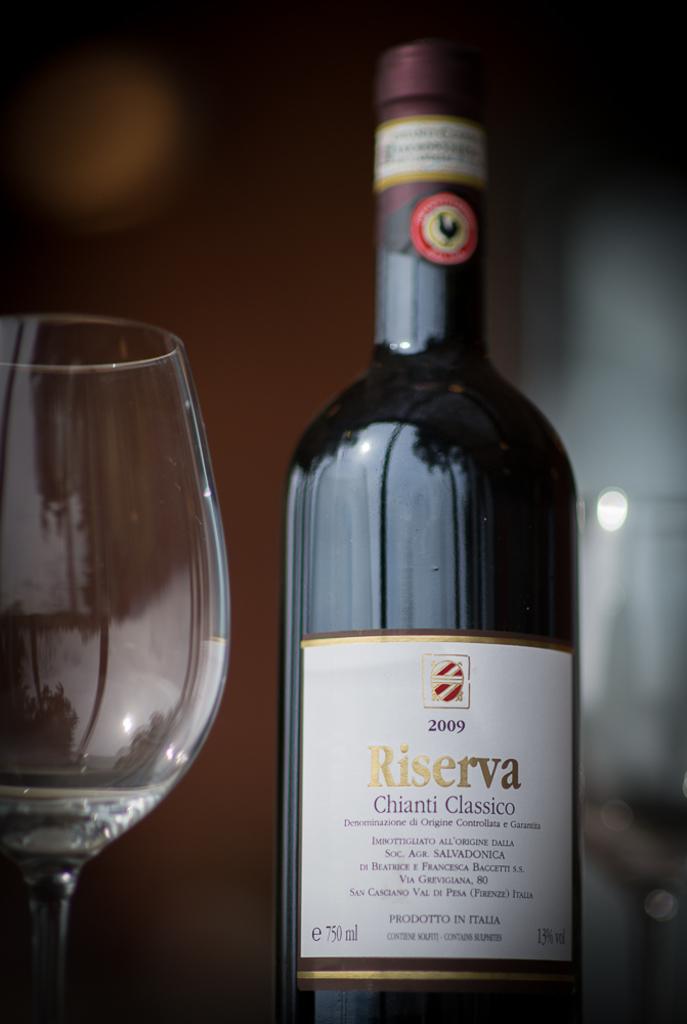What year was this wine made?
Your answer should be compact. 2009. What brand of wine is this?
Provide a short and direct response. Riserva. 